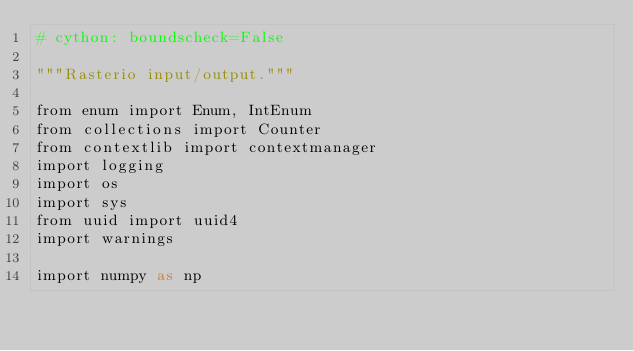Convert code to text. <code><loc_0><loc_0><loc_500><loc_500><_Cython_># cython: boundscheck=False

"""Rasterio input/output."""

from enum import Enum, IntEnum
from collections import Counter
from contextlib import contextmanager
import logging
import os
import sys
from uuid import uuid4
import warnings

import numpy as np
</code> 